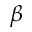<formula> <loc_0><loc_0><loc_500><loc_500>\beta</formula> 